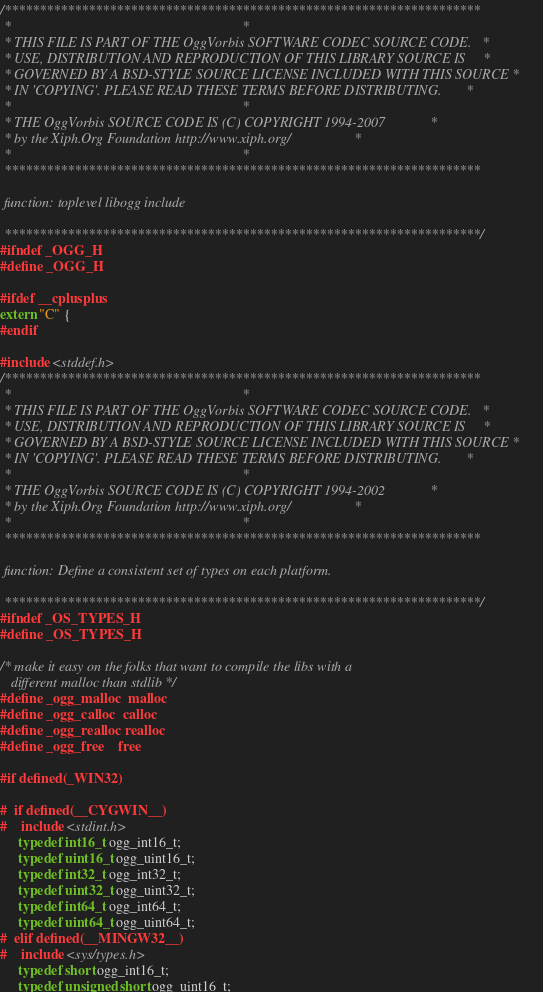<code> <loc_0><loc_0><loc_500><loc_500><_C_>/********************************************************************
 *                                                                  *
 * THIS FILE IS PART OF THE OggVorbis SOFTWARE CODEC SOURCE CODE.   *
 * USE, DISTRIBUTION AND REPRODUCTION OF THIS LIBRARY SOURCE IS     *
 * GOVERNED BY A BSD-STYLE SOURCE LICENSE INCLUDED WITH THIS SOURCE *
 * IN 'COPYING'. PLEASE READ THESE TERMS BEFORE DISTRIBUTING.       *
 *                                                                  *
 * THE OggVorbis SOURCE CODE IS (C) COPYRIGHT 1994-2007             *
 * by the Xiph.Org Foundation http://www.xiph.org/                  *
 *                                                                  *
 ********************************************************************

 function: toplevel libogg include

 ********************************************************************/
#ifndef _OGG_H
#define _OGG_H

#ifdef __cplusplus
extern "C" {
#endif

#include <stddef.h>
/********************************************************************
 *                                                                  *
 * THIS FILE IS PART OF THE OggVorbis SOFTWARE CODEC SOURCE CODE.   *
 * USE, DISTRIBUTION AND REPRODUCTION OF THIS LIBRARY SOURCE IS     *
 * GOVERNED BY A BSD-STYLE SOURCE LICENSE INCLUDED WITH THIS SOURCE *
 * IN 'COPYING'. PLEASE READ THESE TERMS BEFORE DISTRIBUTING.       *
 *                                                                  *
 * THE OggVorbis SOURCE CODE IS (C) COPYRIGHT 1994-2002             *
 * by the Xiph.Org Foundation http://www.xiph.org/                  *
 *                                                                  *
 ********************************************************************

 function: Define a consistent set of types on each platform.

 ********************************************************************/
#ifndef _OS_TYPES_H
#define _OS_TYPES_H

/* make it easy on the folks that want to compile the libs with a
   different malloc than stdlib */
#define _ogg_malloc  malloc
#define _ogg_calloc  calloc
#define _ogg_realloc realloc
#define _ogg_free    free

#if defined(_WIN32)

#  if defined(__CYGWIN__)
#    include <stdint.h>
     typedef int16_t ogg_int16_t;
     typedef uint16_t ogg_uint16_t;
     typedef int32_t ogg_int32_t;
     typedef uint32_t ogg_uint32_t;
     typedef int64_t ogg_int64_t;
     typedef uint64_t ogg_uint64_t;
#  elif defined(__MINGW32__)
#    include <sys/types.h>
     typedef short ogg_int16_t;
     typedef unsigned short ogg_uint16_t;</code> 